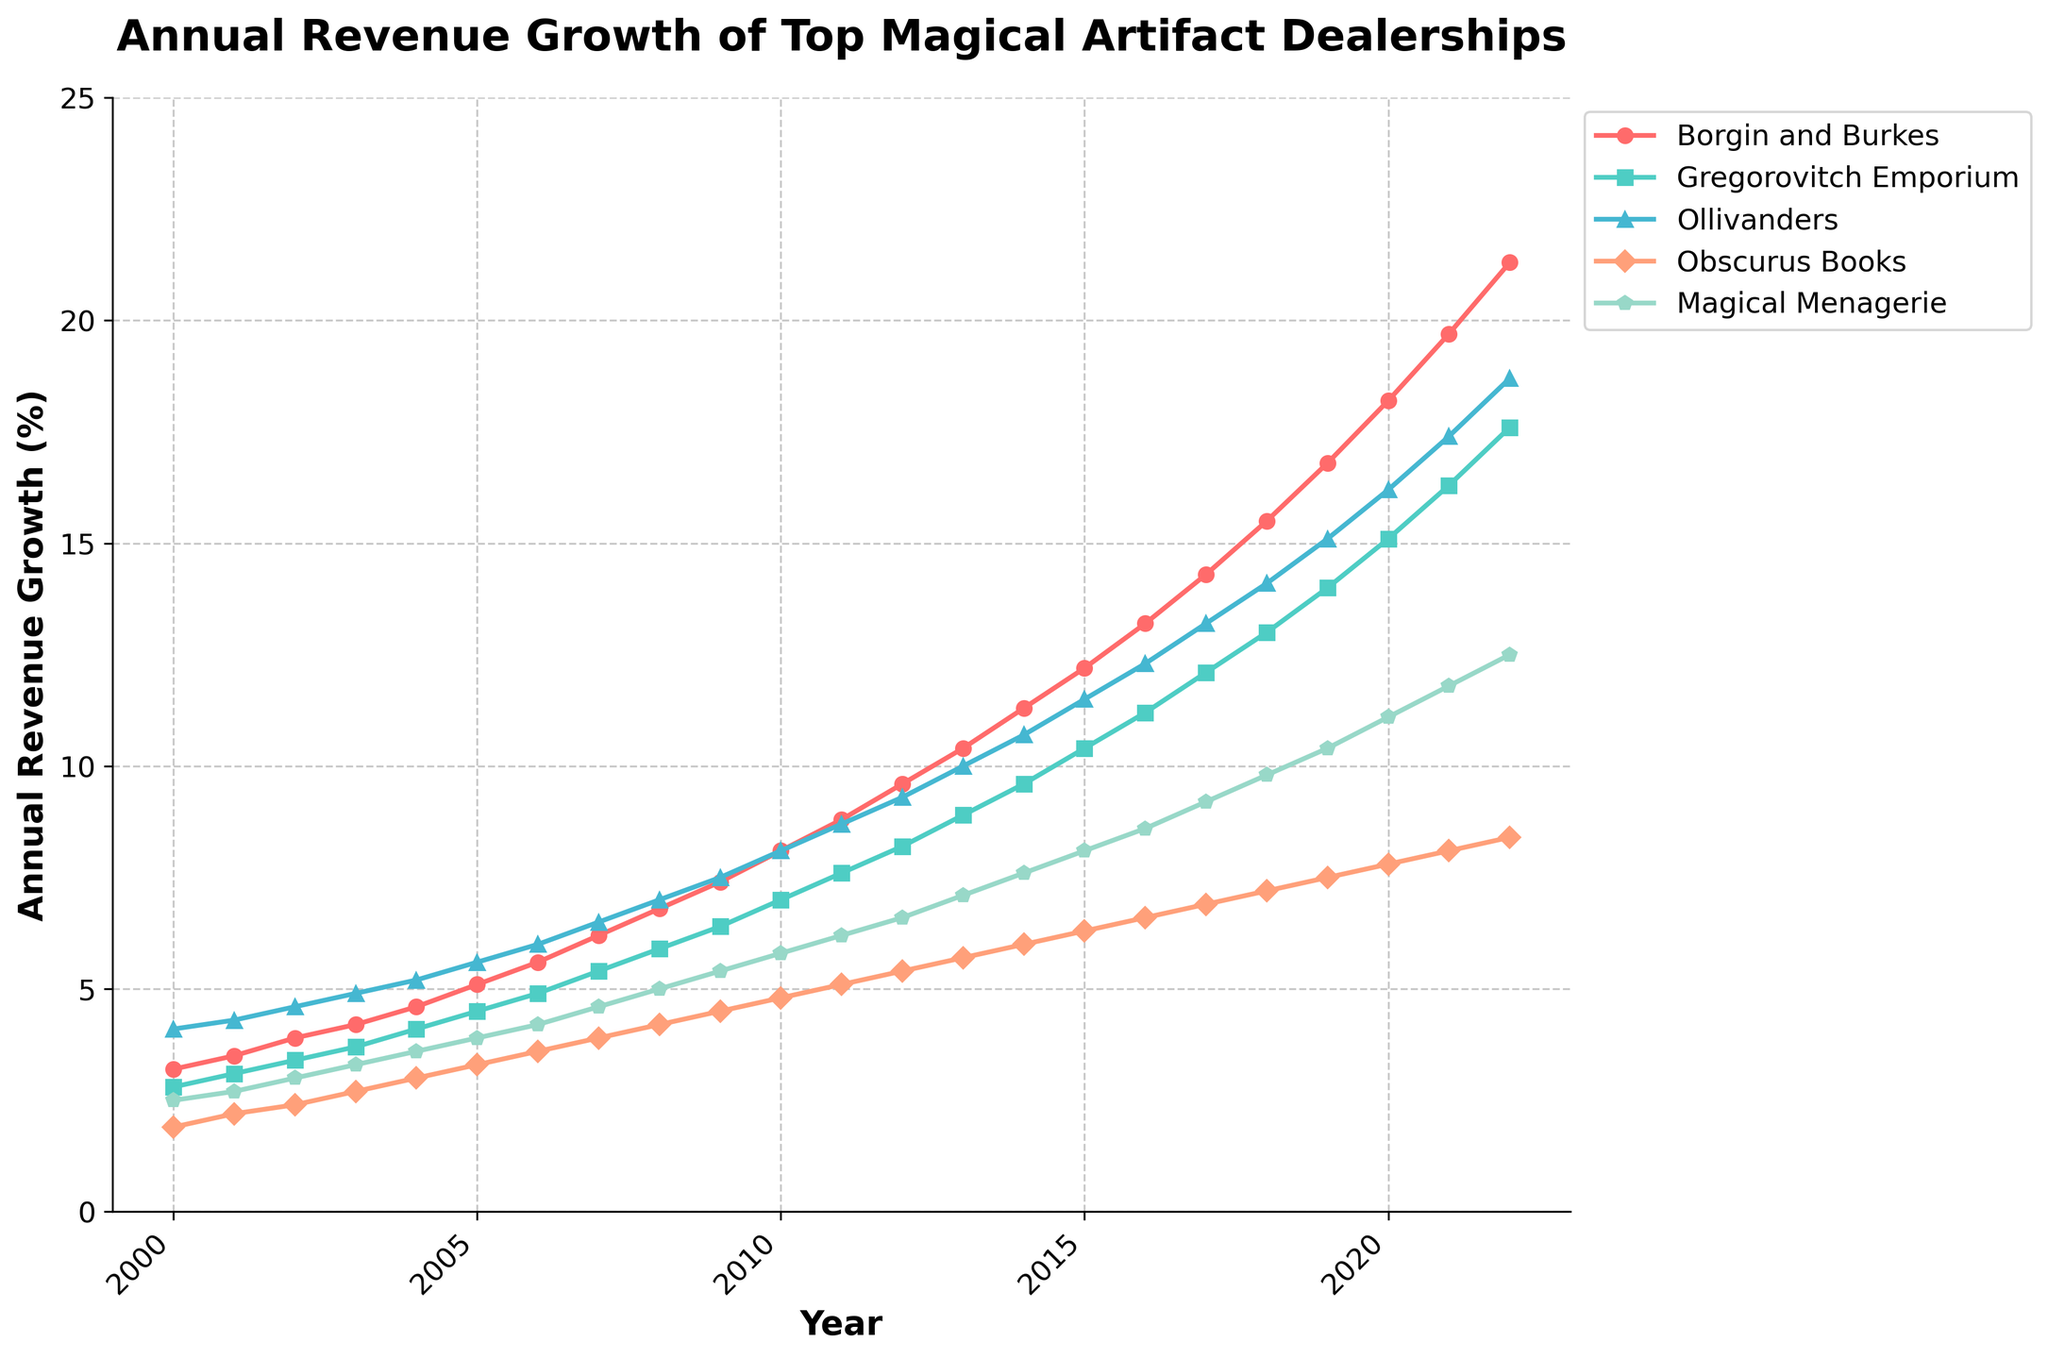What is the overall trend in Ollivanders' annual revenue growth from 2000 to 2022? Analyzing the plot, we see that Ollivanders' revenue growth shows a steady increase over the years, starting from 4.1% in 2000 and reaching 18.7% in 2022. The trend is consistent and upward.
Answer: Steady increase Which dealership had the highest revenue growth in 2022? By examining the plot, we can see that Borgin and Burkes had the highest revenue growth among all dealerships, with a growth rate of 21.3% in 2022.
Answer: Borgin and Burkes How did the revenue growth of Gregorovitch Emporium compare to Magical Menagerie in 2010? According to the figure, Gregorovitch Emporium had a revenue growth of 7.0% in 2010, whereas Magical Menagerie had a growth of 5.8%. Thus, Gregorovitch Emporium's growth was higher.
Answer: Gregorovitch Emporium was higher Between 2005 and 2010, which dealership showed the most significant increase in revenue growth? Analyzing the plot, Borgin and Burkes showed an increase from 5.1% to 8.1%, which is an increase of 3.0 percentage points. Ollivanders increased from 5.6% to 8.1%, also a 2.5 percentage point increase. Borgin and Burkes had the most substantial increase of 3.0 percentage points.
Answer: Borgin and Burkes What is the total revenue growth of Obscurus Books over the entire period (2000-2022)? The total sum of revenue growth for Obscurus Books from each year from 2000 to 2022 is: 1.9 + 2.2 + 2.4 + 2.7 + 3.0 + 3.3 + 3.6 + 3.9 + 4.2 + 4.5 + 4.8 + 5.1 + 5.4 + 5.7 + 6.0 + 6.3 + 6.6 + 6.9 + 7.2 + 7.5 + 7.8 + 8.1 + 8.4 = 125.9.
Answer: 125.9 In which year did Magical Menagerie first surpass 6% annual revenue growth? Looking at the plot, Magical Menagerie's revenue growth surpassed 6% in the year 2013, where it reached 7.1%.
Answer: 2013 What was the combined revenue growth for Gregorovitch Emporium and Ollivanders in 2015? In the year 2015, Gregorovitch Emporium had a revenue growth of 10.4%, and Ollivanders had 11.5%. The combined growth is 10.4 + 11.5 = 21.9.
Answer: 21.9 Between 2010 and 2020, which dealership experienced the greatest increase in annual revenue growth? Borgin and Burkes increased from 8.1% in 2010 to 18.2% in 2020. This is a 10.1 percentage point increase. Gregorovitch Emporium increased from 7.0% to 15.1%, an 8.1 point increase. Ollivanders increased from 8.1% to 16.2%, an 8.1 point increase. Obscurus Books increased from 4.8% to 7.8%, a 3.0 point increase. Magical Menagerie increased from 5.8% to 11.1%, a 5.3 point increase. Borgin and Burkes had the largest increase with 10.1 percentage points.
Answer: Borgin and Burkes Which dealership had the slowest start in 2000 but showed remarkable growth by 2022? In 2000, Obscurus Books had the slowest start with a growth of 1.9%. By 2022, it had grown to 8.4%, representing a significant improvement over the years.
Answer: Obscurus Books 